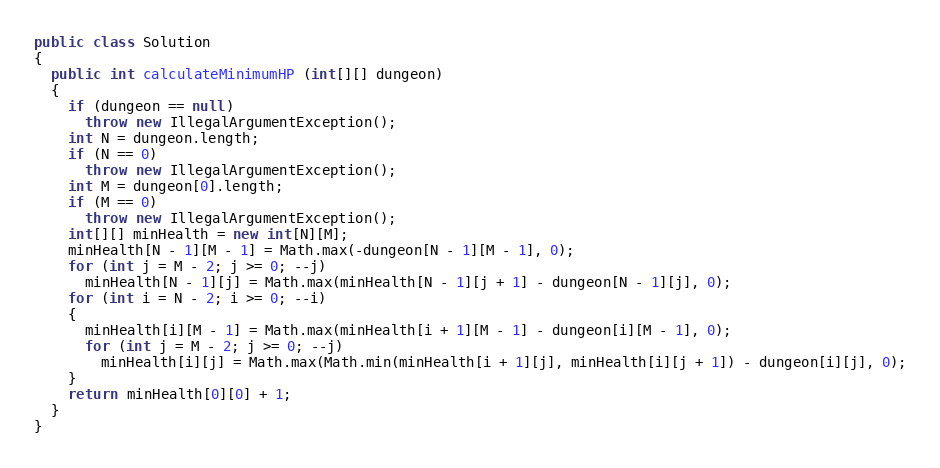Convert code to text. <code><loc_0><loc_0><loc_500><loc_500><_Java_>public class Solution
{
  public int calculateMinimumHP (int[][] dungeon)
  {
    if (dungeon == null)
      throw new IllegalArgumentException();
    int N = dungeon.length;
    if (N == 0)
      throw new IllegalArgumentException();
    int M = dungeon[0].length;
    if (M == 0)
      throw new IllegalArgumentException();
    int[][] minHealth = new int[N][M];
    minHealth[N - 1][M - 1] = Math.max(-dungeon[N - 1][M - 1], 0);
    for (int j = M - 2; j >= 0; --j)
      minHealth[N - 1][j] = Math.max(minHealth[N - 1][j + 1] - dungeon[N - 1][j], 0);
    for (int i = N - 2; i >= 0; --i)
    {
      minHealth[i][M - 1] = Math.max(minHealth[i + 1][M - 1] - dungeon[i][M - 1], 0);
      for (int j = M - 2; j >= 0; --j)
        minHealth[i][j] = Math.max(Math.min(minHealth[i + 1][j], minHealth[i][j + 1]) - dungeon[i][j], 0);
    }
    return minHealth[0][0] + 1;
  }
}
</code> 